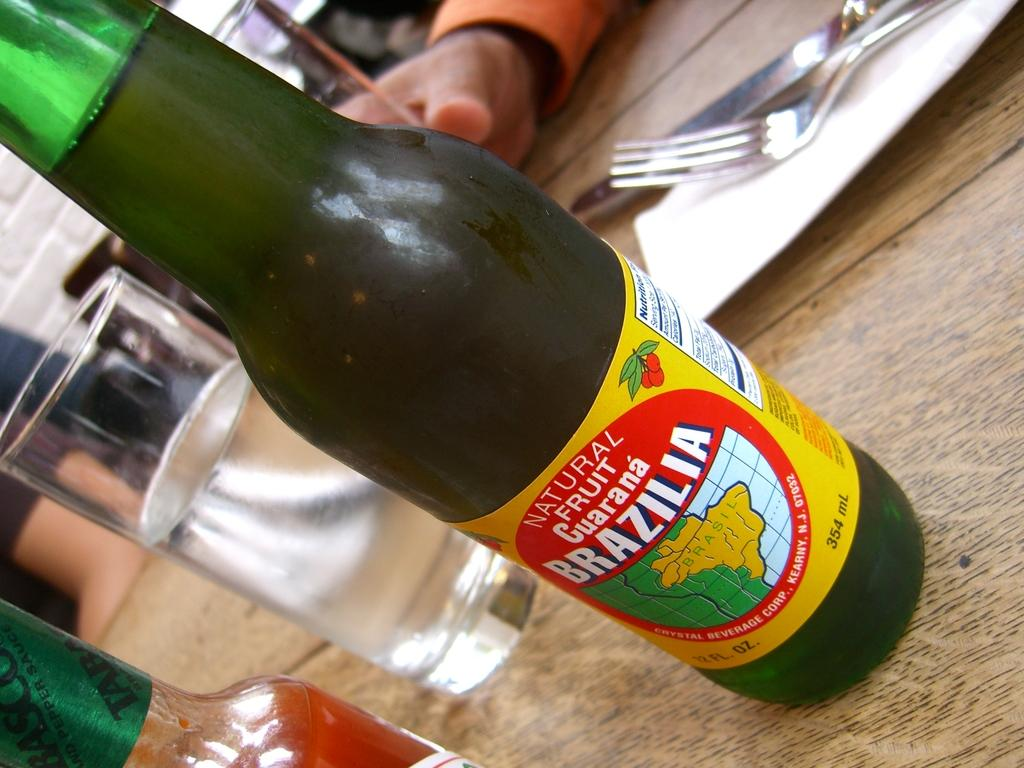<image>
Summarize the visual content of the image. a bottle of Natural Fruit Guarana Brazilia on a table 